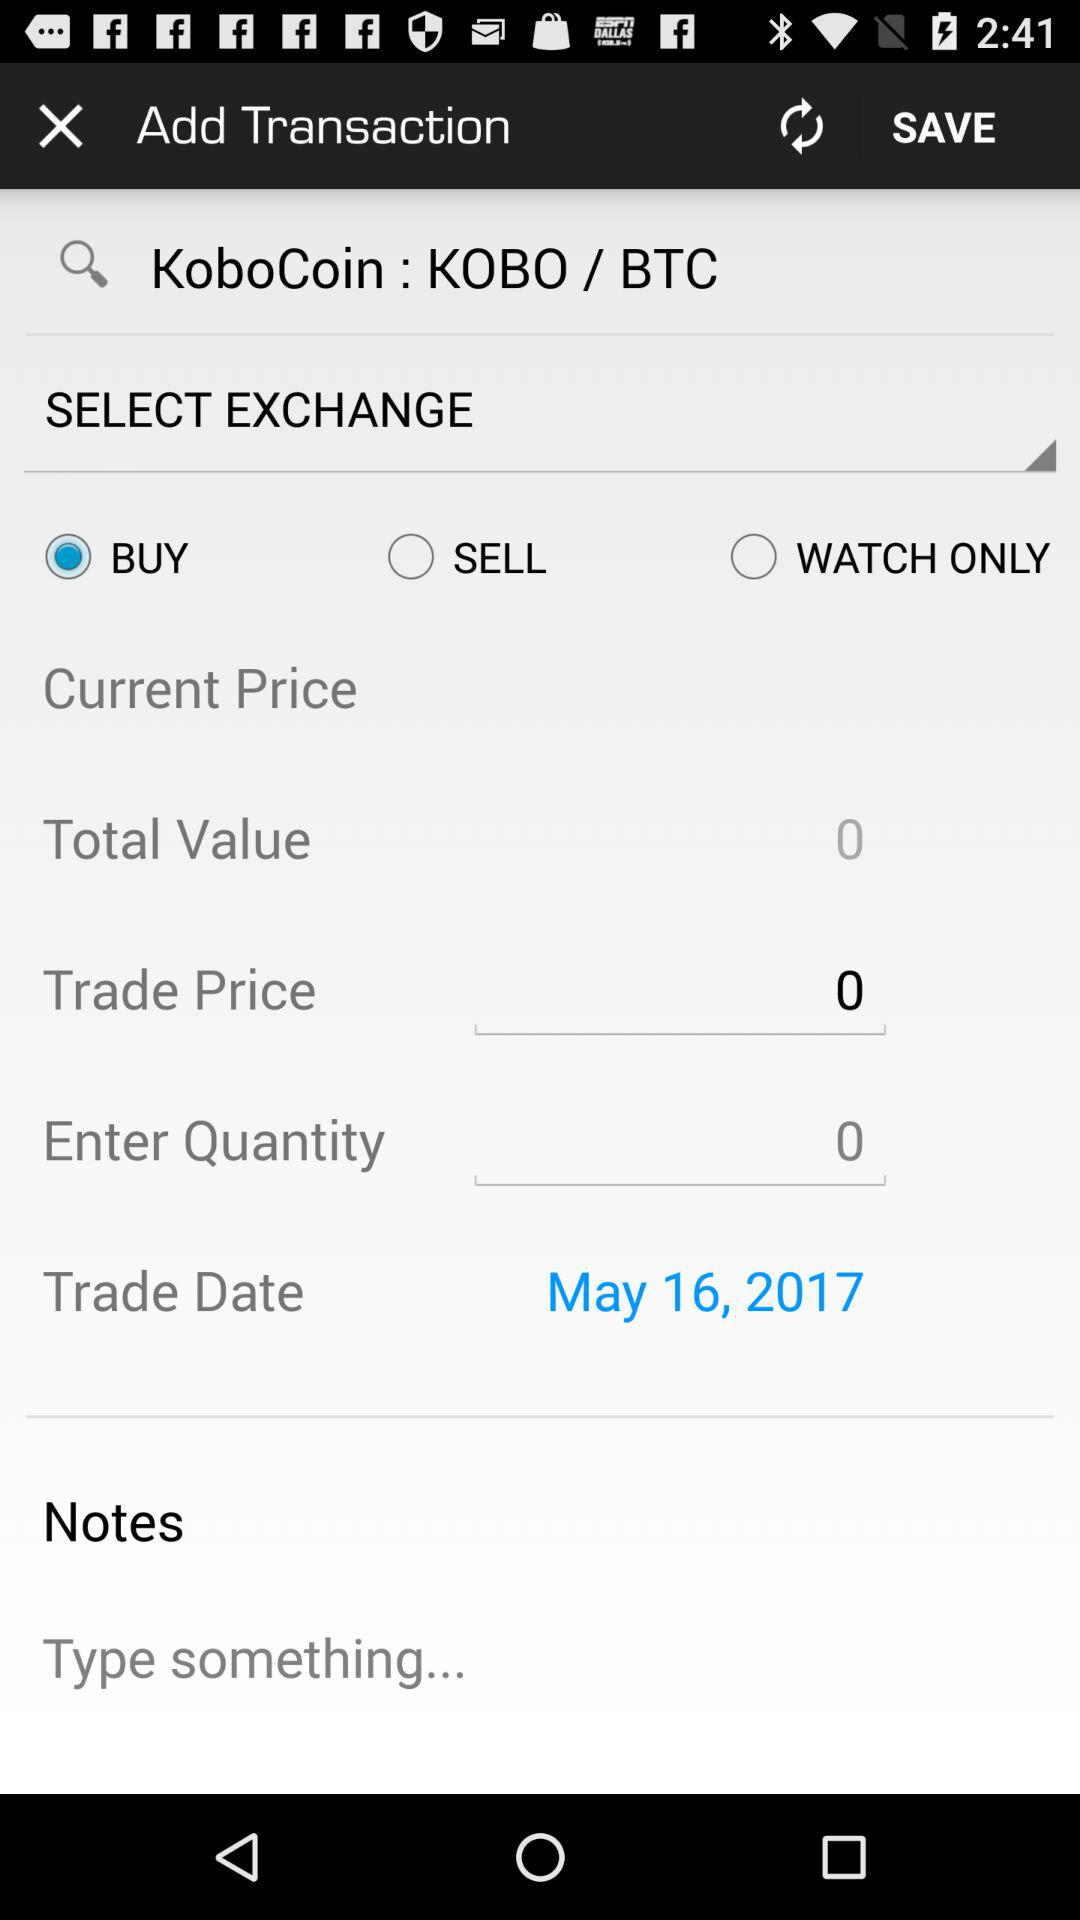What is the trade price? The trade price is 0. 